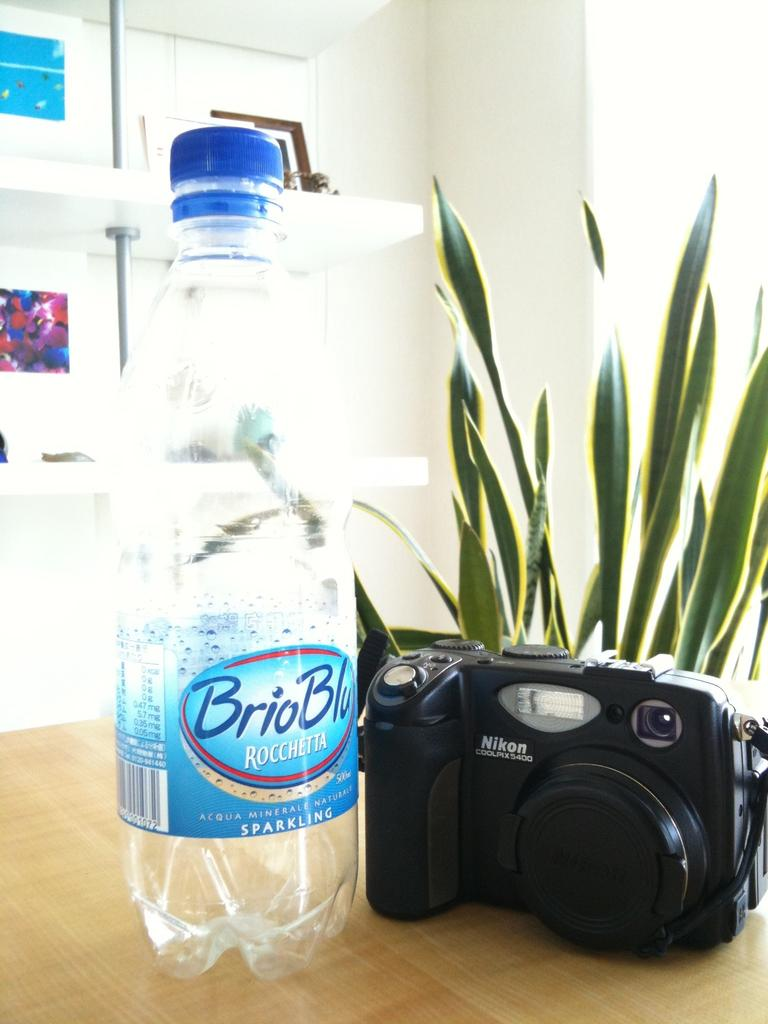What object related to hydration can be seen in the image? There is a water bottle in the image. What device is used for capturing images in the image? There is a camera in the image. What piece of furniture is present in the image? There is a table in the image. What type of plant is visible in the image? There is a house plant in the image. What type of lift is present in the image? There is no lift present in the image. What type of station is visible in the image? There is no station visible in the image. 